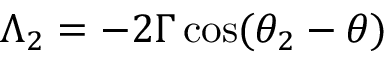<formula> <loc_0><loc_0><loc_500><loc_500>\Lambda _ { 2 } = - 2 \Gamma \, \cos ( \theta _ { 2 } - \theta )</formula> 